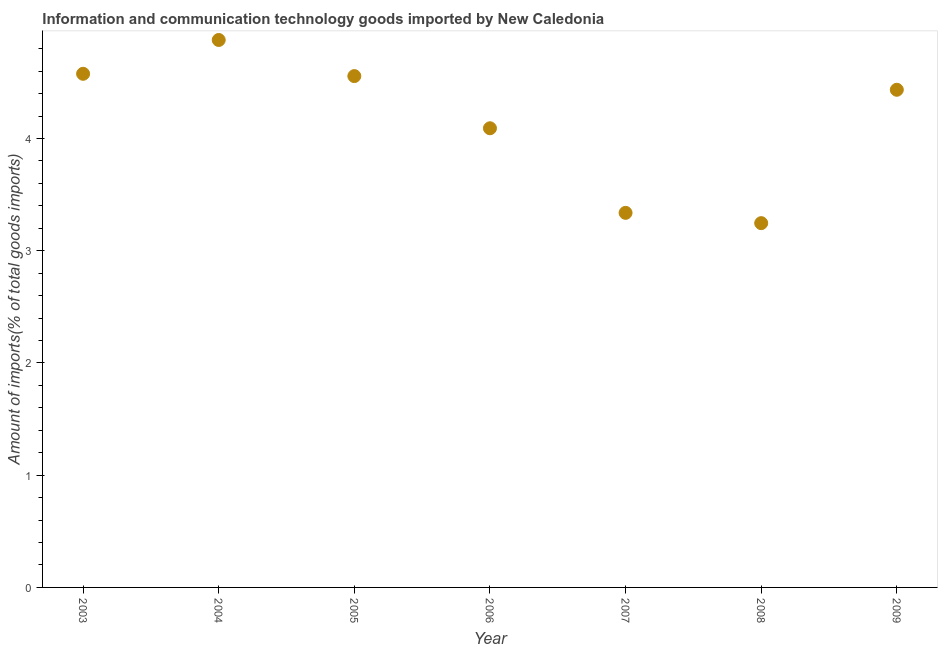What is the amount of ict goods imports in 2009?
Make the answer very short. 4.43. Across all years, what is the maximum amount of ict goods imports?
Your answer should be very brief. 4.88. Across all years, what is the minimum amount of ict goods imports?
Make the answer very short. 3.25. In which year was the amount of ict goods imports maximum?
Your answer should be very brief. 2004. In which year was the amount of ict goods imports minimum?
Your answer should be compact. 2008. What is the sum of the amount of ict goods imports?
Provide a short and direct response. 29.12. What is the difference between the amount of ict goods imports in 2003 and 2009?
Ensure brevity in your answer.  0.14. What is the average amount of ict goods imports per year?
Provide a short and direct response. 4.16. What is the median amount of ict goods imports?
Your answer should be very brief. 4.43. Do a majority of the years between 2009 and 2003 (inclusive) have amount of ict goods imports greater than 3 %?
Offer a very short reply. Yes. What is the ratio of the amount of ict goods imports in 2004 to that in 2006?
Your answer should be very brief. 1.19. Is the difference between the amount of ict goods imports in 2004 and 2006 greater than the difference between any two years?
Your answer should be very brief. No. What is the difference between the highest and the second highest amount of ict goods imports?
Provide a succinct answer. 0.3. Is the sum of the amount of ict goods imports in 2006 and 2007 greater than the maximum amount of ict goods imports across all years?
Your answer should be very brief. Yes. What is the difference between the highest and the lowest amount of ict goods imports?
Ensure brevity in your answer.  1.63. How many dotlines are there?
Offer a very short reply. 1. How many years are there in the graph?
Your answer should be compact. 7. Are the values on the major ticks of Y-axis written in scientific E-notation?
Keep it short and to the point. No. Does the graph contain any zero values?
Your answer should be very brief. No. Does the graph contain grids?
Provide a short and direct response. No. What is the title of the graph?
Provide a short and direct response. Information and communication technology goods imported by New Caledonia. What is the label or title of the Y-axis?
Your answer should be compact. Amount of imports(% of total goods imports). What is the Amount of imports(% of total goods imports) in 2003?
Keep it short and to the point. 4.58. What is the Amount of imports(% of total goods imports) in 2004?
Make the answer very short. 4.88. What is the Amount of imports(% of total goods imports) in 2005?
Ensure brevity in your answer.  4.56. What is the Amount of imports(% of total goods imports) in 2006?
Provide a short and direct response. 4.09. What is the Amount of imports(% of total goods imports) in 2007?
Ensure brevity in your answer.  3.34. What is the Amount of imports(% of total goods imports) in 2008?
Offer a very short reply. 3.25. What is the Amount of imports(% of total goods imports) in 2009?
Your answer should be compact. 4.43. What is the difference between the Amount of imports(% of total goods imports) in 2003 and 2004?
Offer a very short reply. -0.3. What is the difference between the Amount of imports(% of total goods imports) in 2003 and 2005?
Provide a succinct answer. 0.02. What is the difference between the Amount of imports(% of total goods imports) in 2003 and 2006?
Provide a succinct answer. 0.49. What is the difference between the Amount of imports(% of total goods imports) in 2003 and 2007?
Your answer should be compact. 1.24. What is the difference between the Amount of imports(% of total goods imports) in 2003 and 2008?
Offer a terse response. 1.33. What is the difference between the Amount of imports(% of total goods imports) in 2003 and 2009?
Keep it short and to the point. 0.14. What is the difference between the Amount of imports(% of total goods imports) in 2004 and 2005?
Provide a succinct answer. 0.32. What is the difference between the Amount of imports(% of total goods imports) in 2004 and 2006?
Your answer should be compact. 0.79. What is the difference between the Amount of imports(% of total goods imports) in 2004 and 2007?
Make the answer very short. 1.54. What is the difference between the Amount of imports(% of total goods imports) in 2004 and 2008?
Your answer should be compact. 1.63. What is the difference between the Amount of imports(% of total goods imports) in 2004 and 2009?
Offer a very short reply. 0.44. What is the difference between the Amount of imports(% of total goods imports) in 2005 and 2006?
Your answer should be very brief. 0.46. What is the difference between the Amount of imports(% of total goods imports) in 2005 and 2007?
Provide a short and direct response. 1.22. What is the difference between the Amount of imports(% of total goods imports) in 2005 and 2008?
Provide a short and direct response. 1.31. What is the difference between the Amount of imports(% of total goods imports) in 2005 and 2009?
Give a very brief answer. 0.12. What is the difference between the Amount of imports(% of total goods imports) in 2006 and 2007?
Ensure brevity in your answer.  0.75. What is the difference between the Amount of imports(% of total goods imports) in 2006 and 2008?
Offer a very short reply. 0.85. What is the difference between the Amount of imports(% of total goods imports) in 2006 and 2009?
Your answer should be very brief. -0.34. What is the difference between the Amount of imports(% of total goods imports) in 2007 and 2008?
Keep it short and to the point. 0.09. What is the difference between the Amount of imports(% of total goods imports) in 2007 and 2009?
Ensure brevity in your answer.  -1.1. What is the difference between the Amount of imports(% of total goods imports) in 2008 and 2009?
Your response must be concise. -1.19. What is the ratio of the Amount of imports(% of total goods imports) in 2003 to that in 2004?
Offer a terse response. 0.94. What is the ratio of the Amount of imports(% of total goods imports) in 2003 to that in 2005?
Offer a terse response. 1. What is the ratio of the Amount of imports(% of total goods imports) in 2003 to that in 2006?
Your response must be concise. 1.12. What is the ratio of the Amount of imports(% of total goods imports) in 2003 to that in 2007?
Offer a very short reply. 1.37. What is the ratio of the Amount of imports(% of total goods imports) in 2003 to that in 2008?
Make the answer very short. 1.41. What is the ratio of the Amount of imports(% of total goods imports) in 2003 to that in 2009?
Ensure brevity in your answer.  1.03. What is the ratio of the Amount of imports(% of total goods imports) in 2004 to that in 2005?
Your answer should be compact. 1.07. What is the ratio of the Amount of imports(% of total goods imports) in 2004 to that in 2006?
Provide a succinct answer. 1.19. What is the ratio of the Amount of imports(% of total goods imports) in 2004 to that in 2007?
Provide a succinct answer. 1.46. What is the ratio of the Amount of imports(% of total goods imports) in 2004 to that in 2008?
Your answer should be compact. 1.5. What is the ratio of the Amount of imports(% of total goods imports) in 2004 to that in 2009?
Provide a short and direct response. 1.1. What is the ratio of the Amount of imports(% of total goods imports) in 2005 to that in 2006?
Your answer should be very brief. 1.11. What is the ratio of the Amount of imports(% of total goods imports) in 2005 to that in 2007?
Offer a terse response. 1.36. What is the ratio of the Amount of imports(% of total goods imports) in 2005 to that in 2008?
Keep it short and to the point. 1.4. What is the ratio of the Amount of imports(% of total goods imports) in 2006 to that in 2007?
Your answer should be very brief. 1.23. What is the ratio of the Amount of imports(% of total goods imports) in 2006 to that in 2008?
Make the answer very short. 1.26. What is the ratio of the Amount of imports(% of total goods imports) in 2006 to that in 2009?
Offer a terse response. 0.92. What is the ratio of the Amount of imports(% of total goods imports) in 2007 to that in 2008?
Offer a very short reply. 1.03. What is the ratio of the Amount of imports(% of total goods imports) in 2007 to that in 2009?
Your answer should be very brief. 0.75. What is the ratio of the Amount of imports(% of total goods imports) in 2008 to that in 2009?
Ensure brevity in your answer.  0.73. 